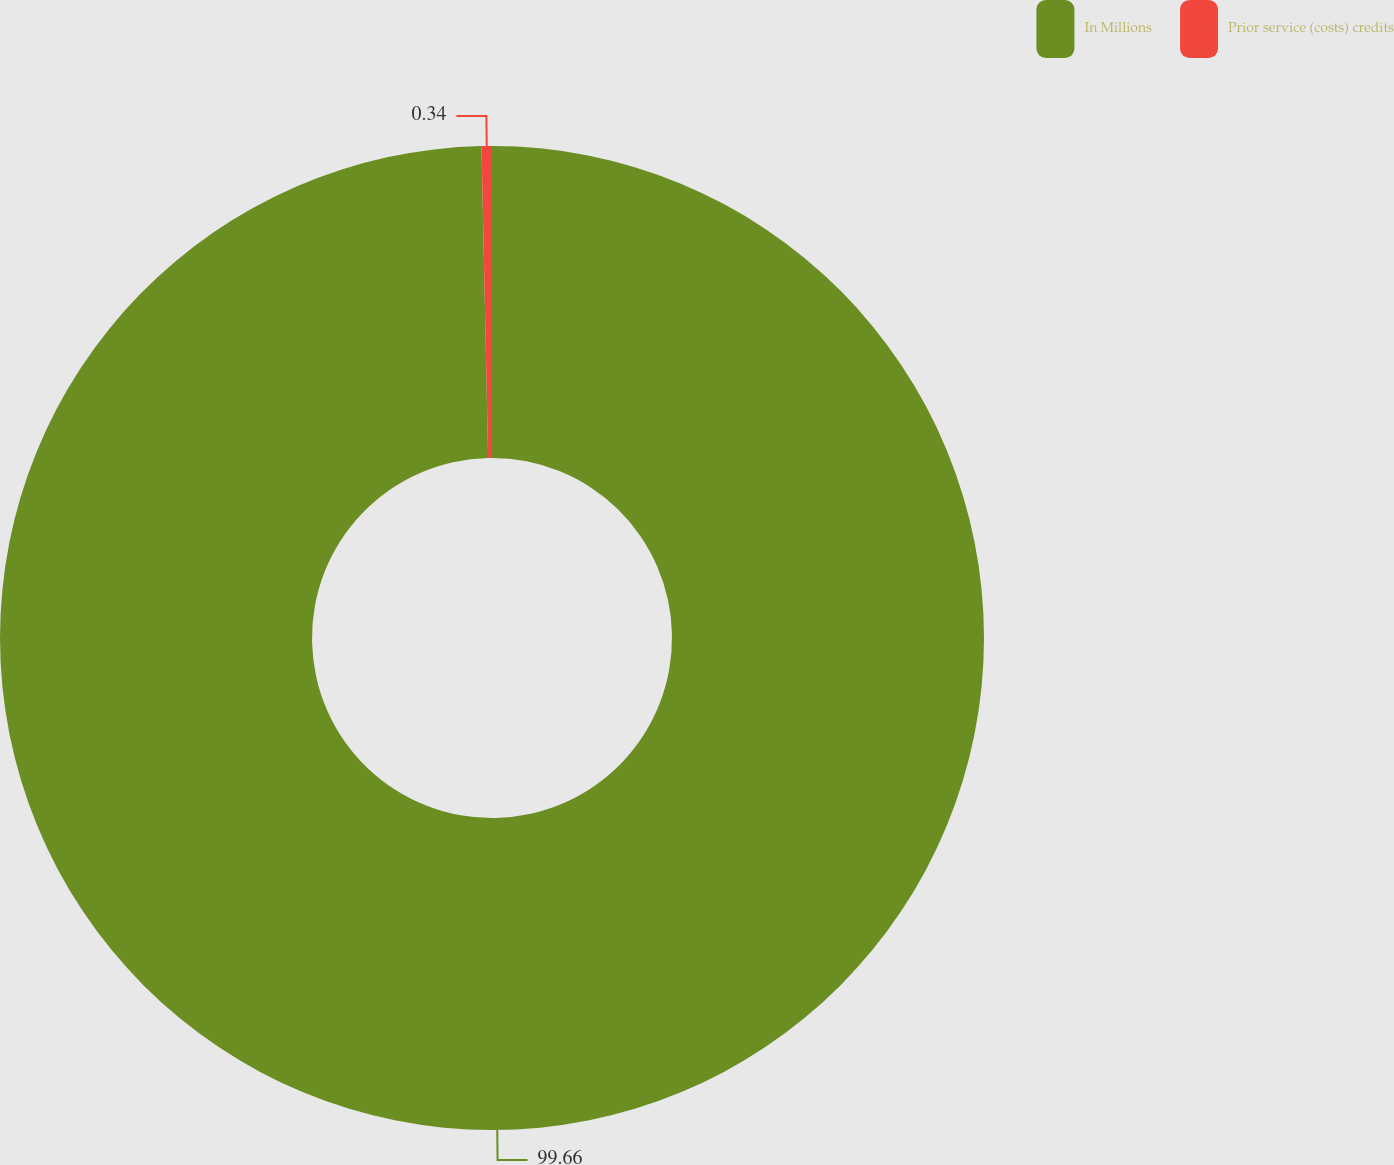<chart> <loc_0><loc_0><loc_500><loc_500><pie_chart><fcel>In Millions<fcel>Prior service (costs) credits<nl><fcel>99.66%<fcel>0.34%<nl></chart> 